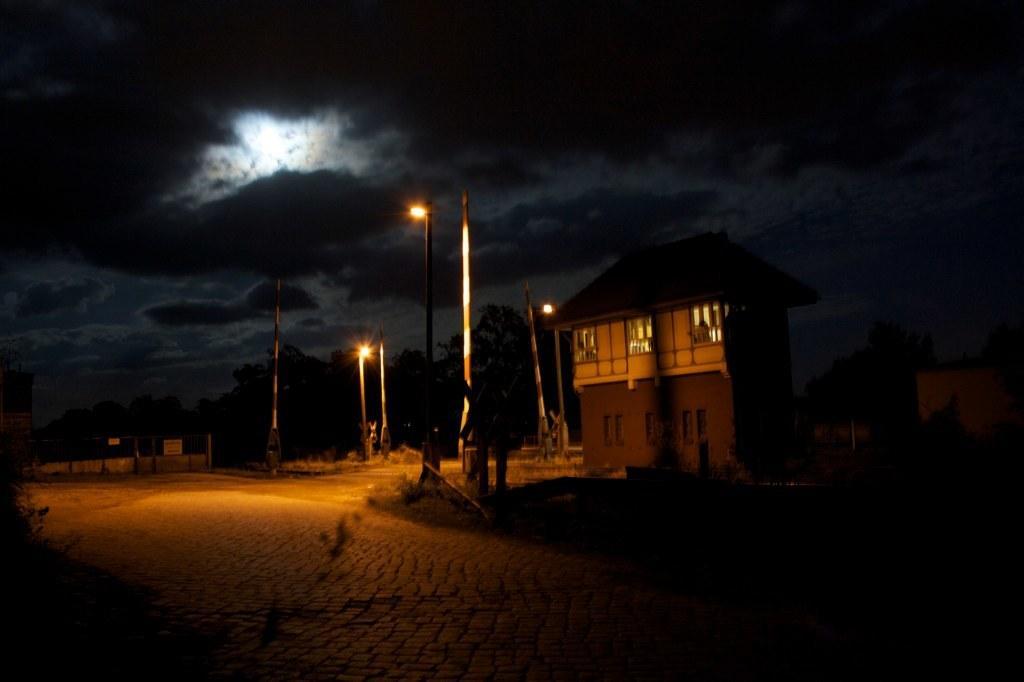Please provide a concise description of this image. In this picture, we see a building in white and brown color. Beside that, there are poles and street lights. At the bottom of the picture, we see the road and at the top of the picture, we see the sky. This picture is clicked in the dark. 